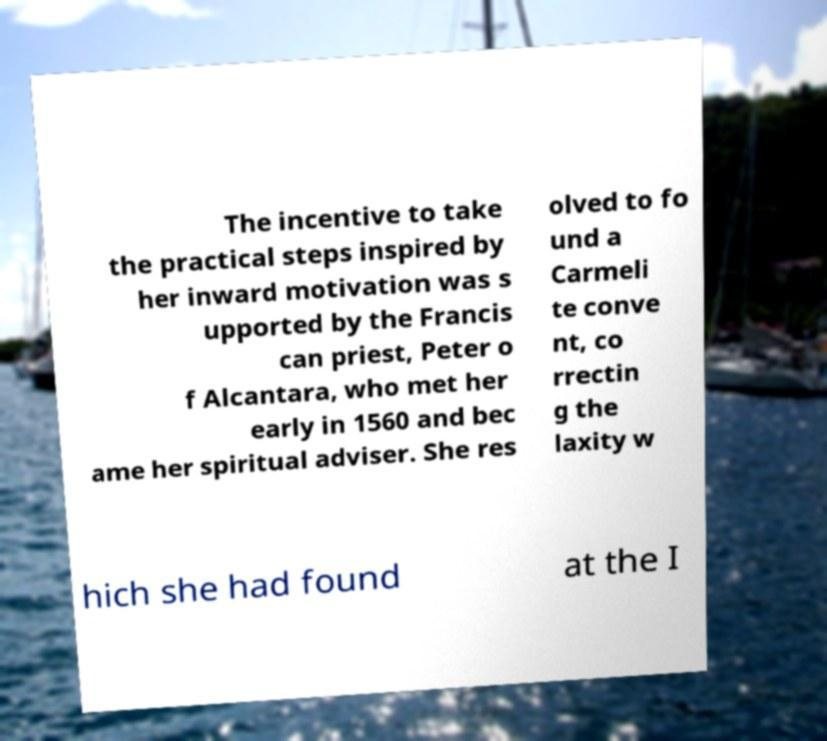The historical context seems interesting. Can you provide insight into the significance of the Carmelite convent reforms referenced? The Carmelite convent reforms, often termed the Discalced Carmelite Reform, were significant because they marked a return to stricter ascetic practices and a contemplative life within the Order. Initiatives like these were part of the larger Counter-Reformation movement within the Catholic Church, aimed at both spiritual renewal and combating the theological challenges posed by the Protestant Reformation. The push for reform reflected a desire for a more austere, devotional, and spiritually disciplined life among the nuns and monks of the Carmelite Order. 